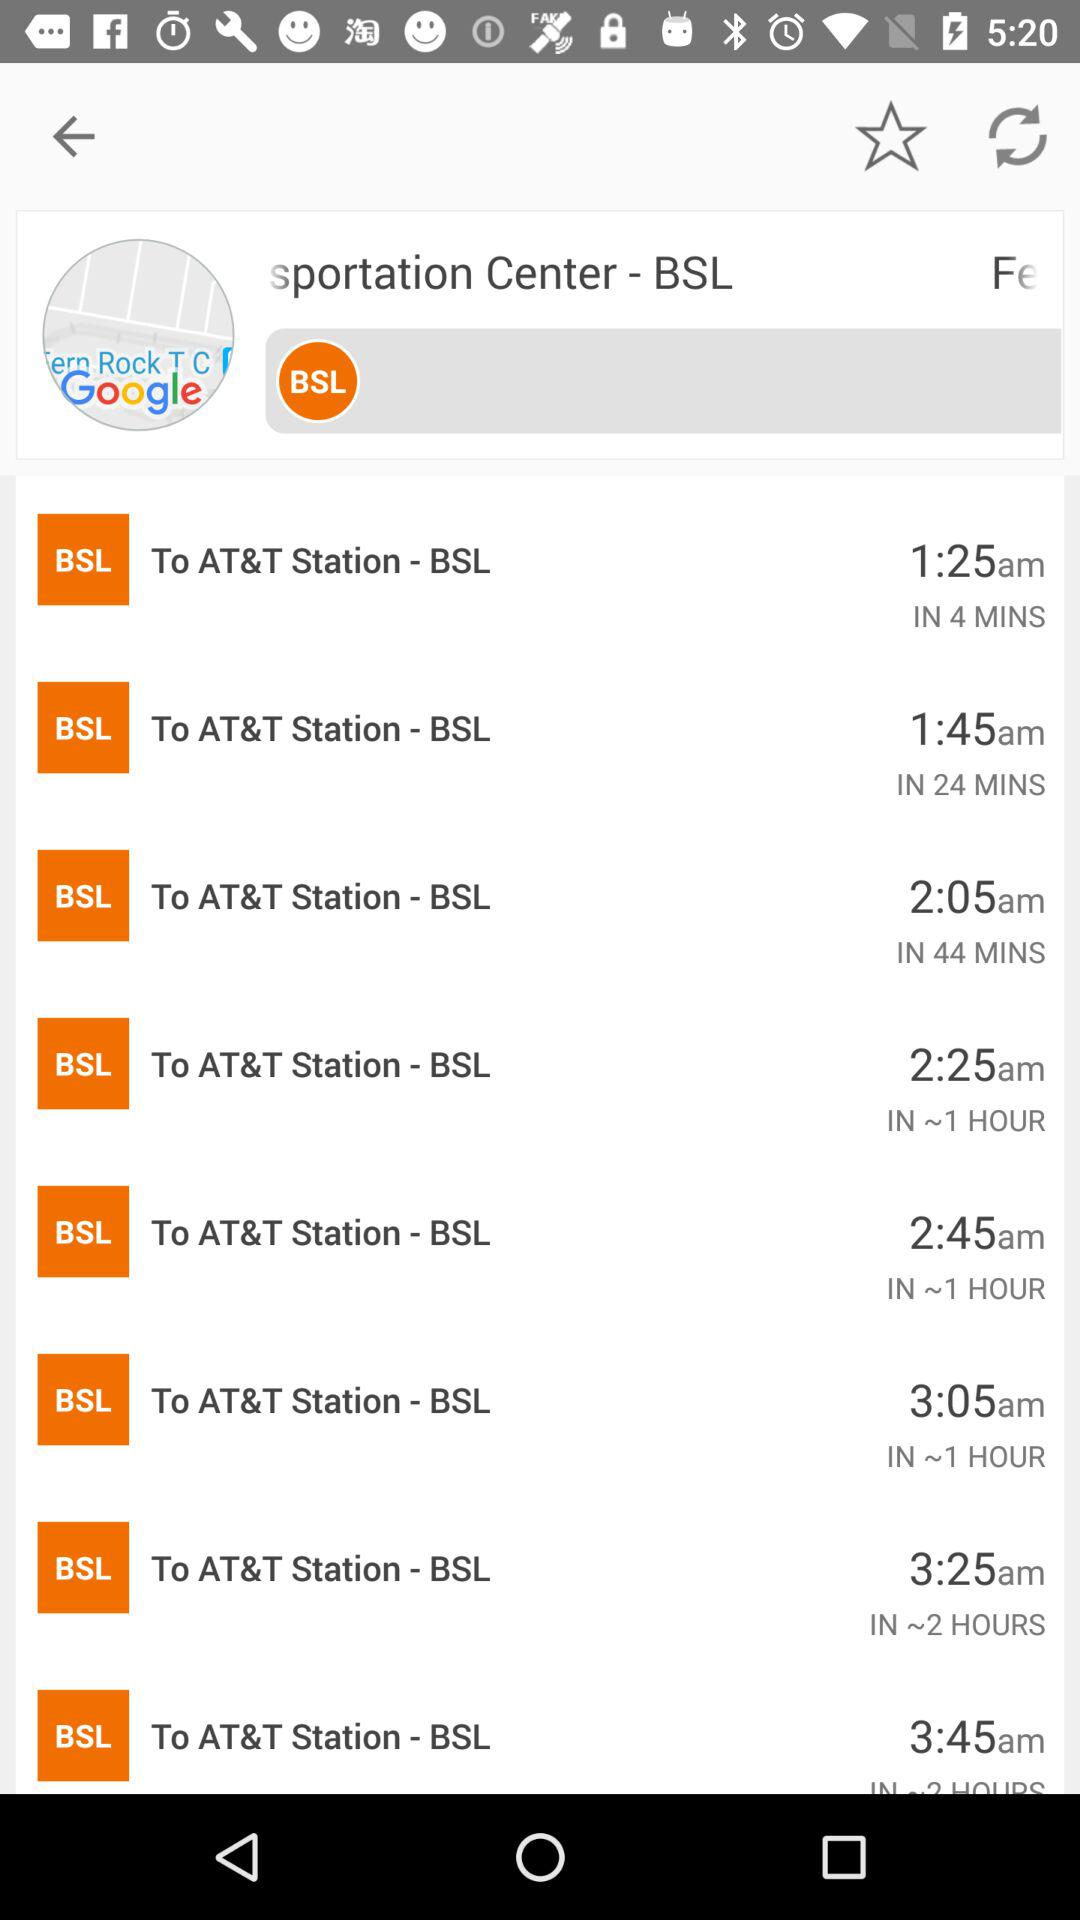What is the app name? The app name is "Sportation Centre - BSL". 